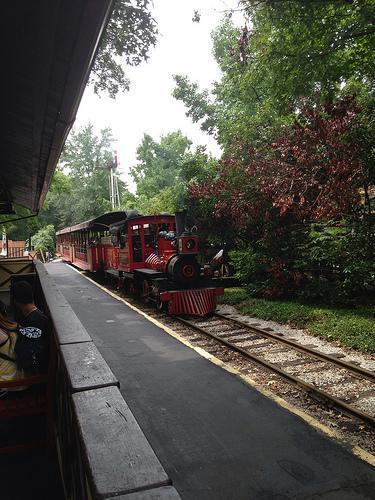How many people are visible?
Give a very brief answer. 1. 